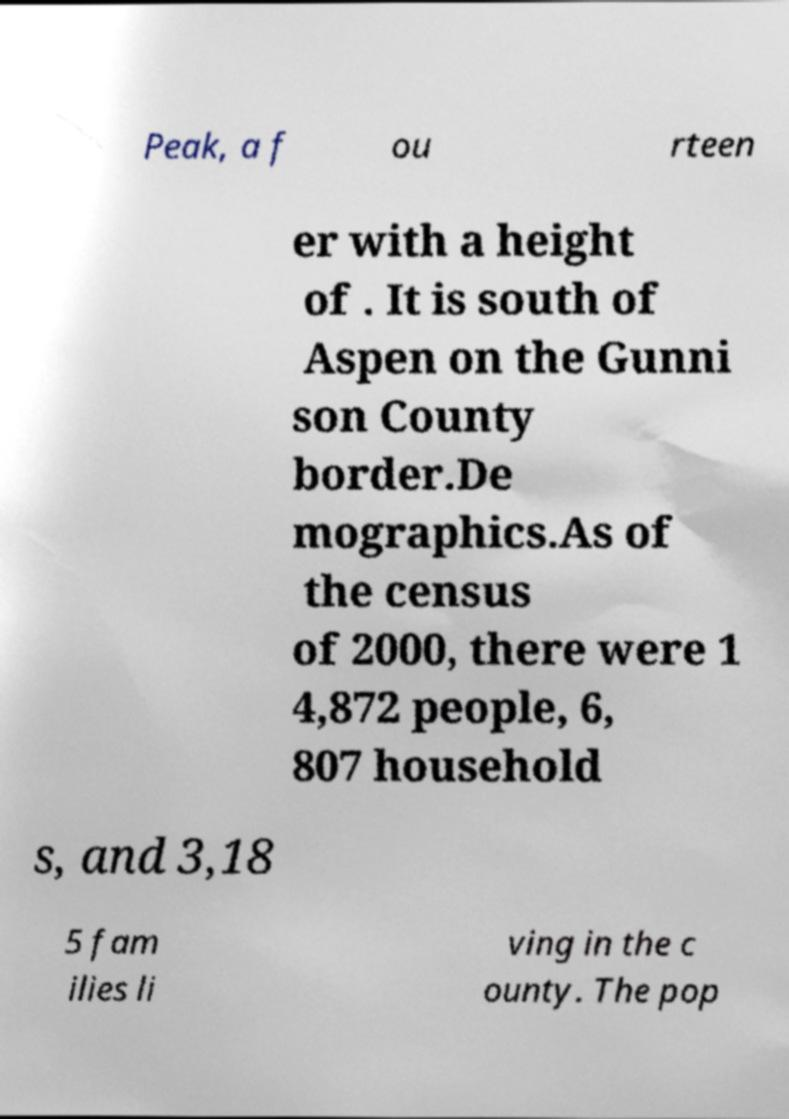There's text embedded in this image that I need extracted. Can you transcribe it verbatim? Peak, a f ou rteen er with a height of . It is south of Aspen on the Gunni son County border.De mographics.As of the census of 2000, there were 1 4,872 people, 6, 807 household s, and 3,18 5 fam ilies li ving in the c ounty. The pop 